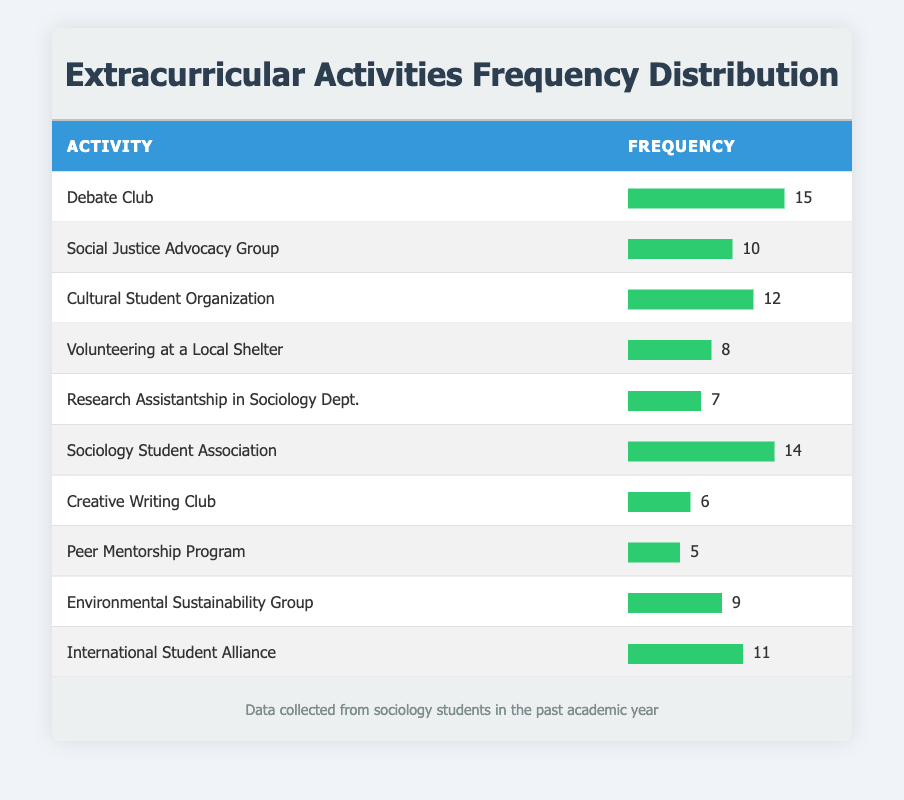What is the most participated extracurricular activity? The highest frequency in the table indicates the most participated activity. Looking through the frequencies, "Debate Club" has the highest frequency of 15 participants.
Answer: Debate Club How many sociology students participated in the "International Student Alliance"? The frequency provided for "International Student Alliance" in the table is 11, indicating the number of sociology students who participated in this activity.
Answer: 11 What is the average frequency of participation for the extracurricular activities listed? To find the average frequency, sum up the frequencies: 15 + 10 + 12 + 8 + 7 + 14 + 6 + 5 + 9 + 11 = 87. There are 10 activities, so the average is 87 / 10 = 8.7.
Answer: 8.7 Is the frequency of participation in "Volunteering at a Local Shelter" higher than that in "Peer Mentorship Program"? From the table, "Volunteering at a Local Shelter" has a frequency of 8, while "Peer Mentorship Program" has a lower frequency of 5. Since 8 is greater than 5, the statement is true.
Answer: Yes What is the total frequency of participation in the top three activities? The three activities with the highest frequencies are "Debate Club" (15), "Sociology Student Association" (14), and "Cultural Student Organization" (12). Adding them: 15 + 14 + 12 = 41. Therefore, the total frequency of the top three activities is 41.
Answer: 41 Which activity had the lowest frequency, and what is that frequency? "Creative Writing Club" has the lowest frequency of 6 based on the data in the table. Analyzing all the activities, the one with the least number is indeed "Creative Writing Club" at 6.
Answer: Creative Writing Club, 6 How many more students participated in "Sociology Student Association" compared to "Research Assistantship in Sociology Dept."? "Sociology Student Association" has a frequency of 14, and "Research Assistantship in Sociology Dept." has a frequency of 7. The difference in participation is 14 - 7 = 7.
Answer: 7 Are there more students involved in "Environmental Sustainability Group" than in "Social Justice Advocacy Group"? The frequencies are checked for both activities: "Environmental Sustainability Group" has 9, while "Social Justice Advocacy Group" has 10. Since 9 is less than 10, there are not more students in "Environmental Sustainability Group".
Answer: No 